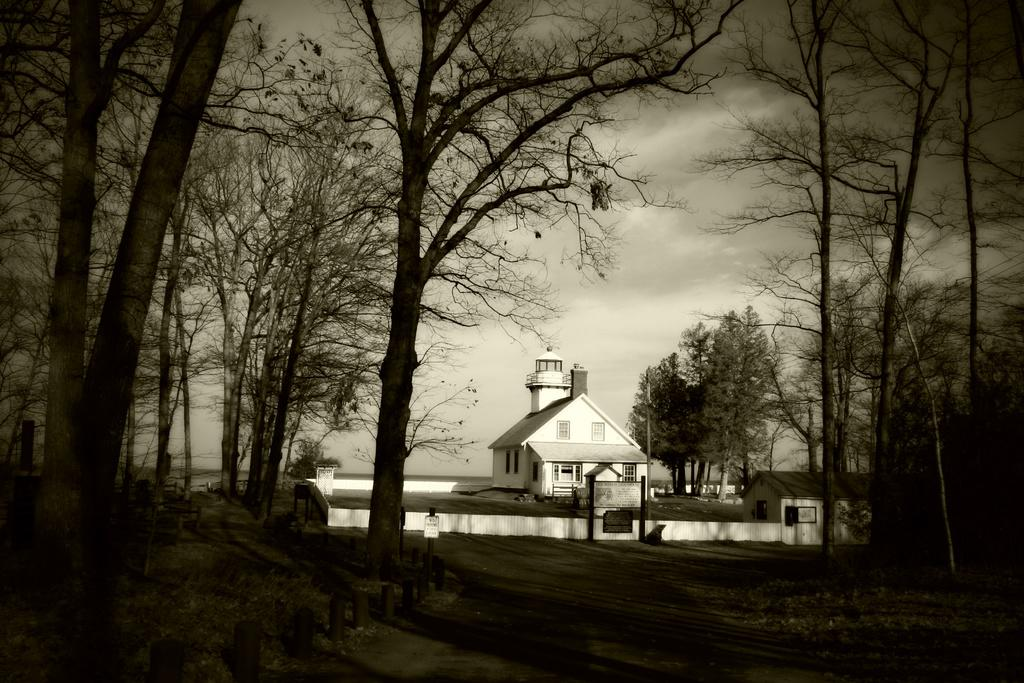What is the color scheme of the image? The image is black and white. What type of structures can be seen in the image? There are houses in the image. What type of vegetation is present in the image? There are trees in the image. What other objects can be seen in the image? There are boards, poles, and grass in the bottom of the image. There is also a road in the bottom of the image. What is visible in the background of the image? The sky is visible in the background of the image. How many cents are visible in the image? There are no cents present in the image. What type of curtain can be seen hanging from the houses in the image? There are no curtains visible in the image; the houses are black and white and do not have any visible window treatments. 